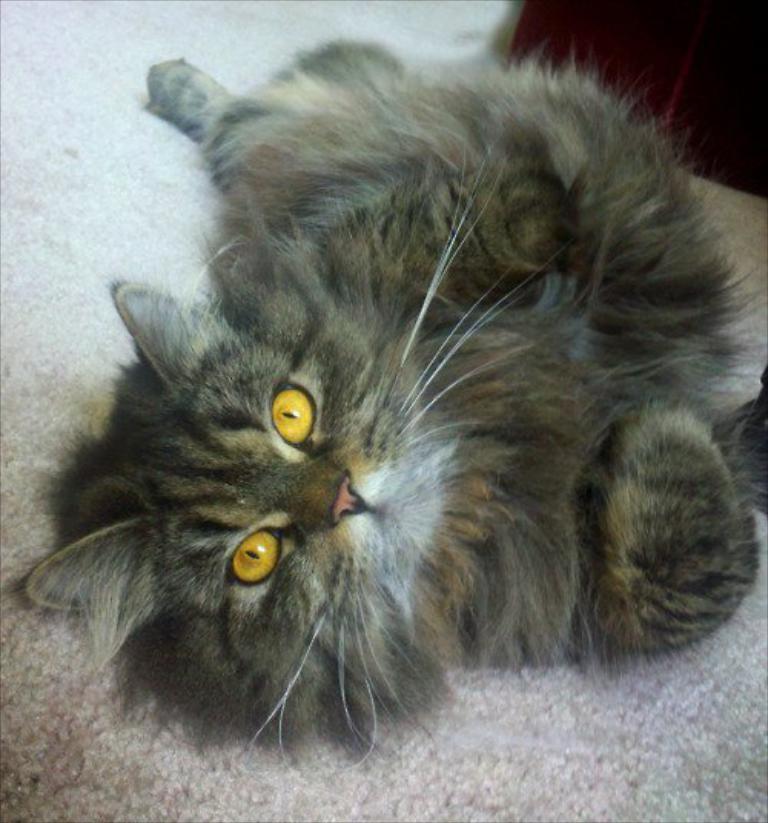Describe this image in one or two sentences. In this picture there is a cat in the center of the image. 